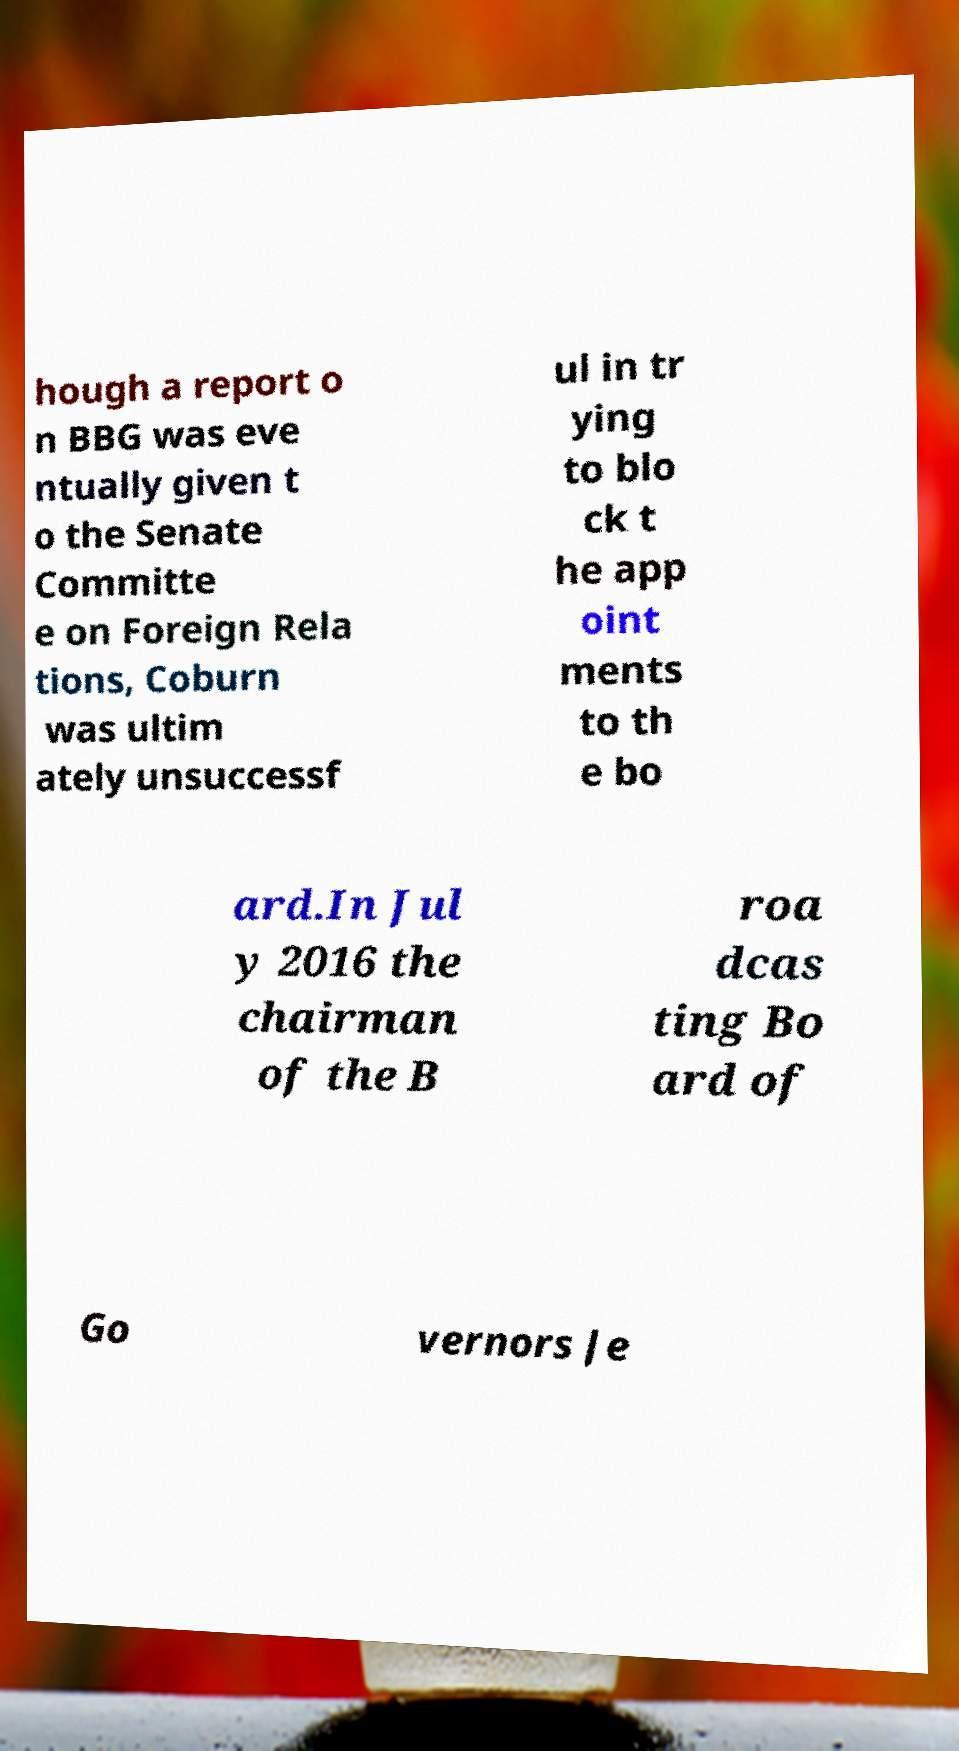I need the written content from this picture converted into text. Can you do that? hough a report o n BBG was eve ntually given t o the Senate Committe e on Foreign Rela tions, Coburn was ultim ately unsuccessf ul in tr ying to blo ck t he app oint ments to th e bo ard.In Jul y 2016 the chairman of the B roa dcas ting Bo ard of Go vernors Je 